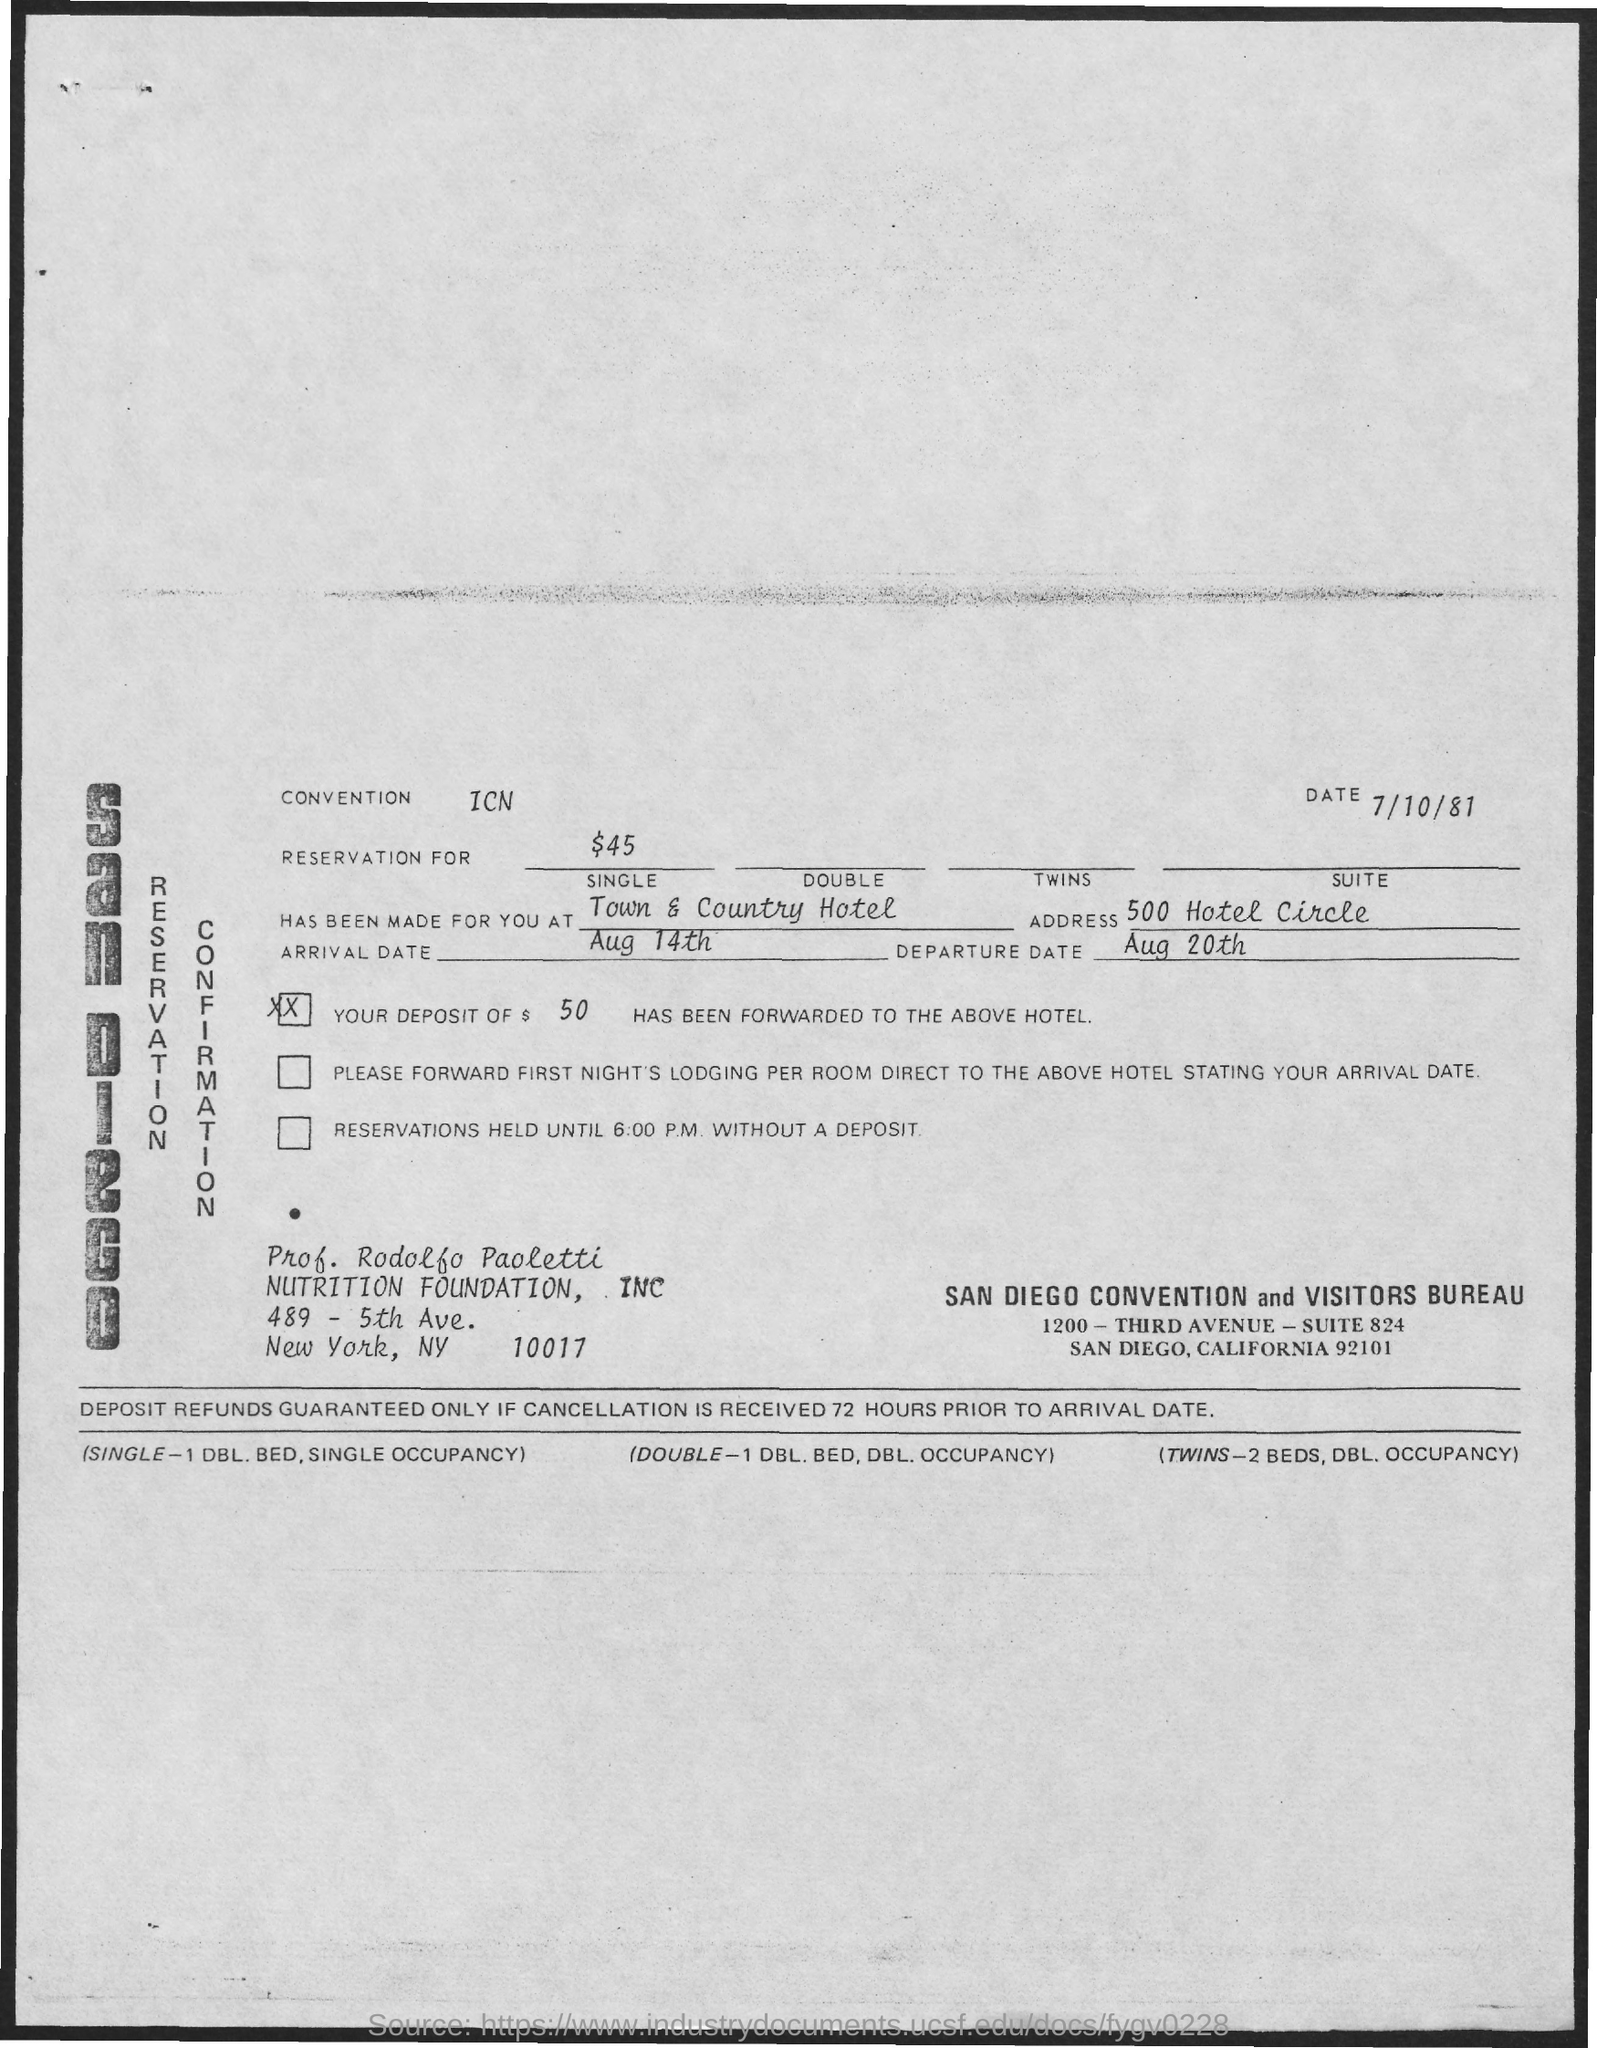What is the date mentioned in the top of the document ?
Ensure brevity in your answer.  7/10/81. What is written in the Convention Field ?
Make the answer very short. ICN. What is the Arrival Date ?
Provide a succinct answer. Aug 14th. What is the Departure Date ?
Your answer should be very brief. Aug 20th. 